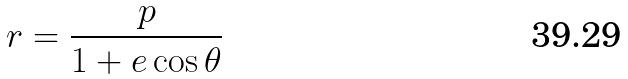Convert formula to latex. <formula><loc_0><loc_0><loc_500><loc_500>r = \frac { p } { 1 + e \cos \theta }</formula> 